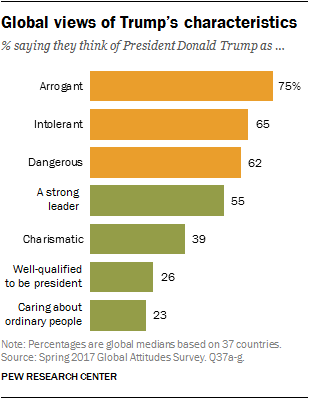Draw attention to some important aspects in this diagram. According to the data, 62% of respondents believe that President Donald Trump is dangerous. The average of green bars is not greater than the average of orange bars. 